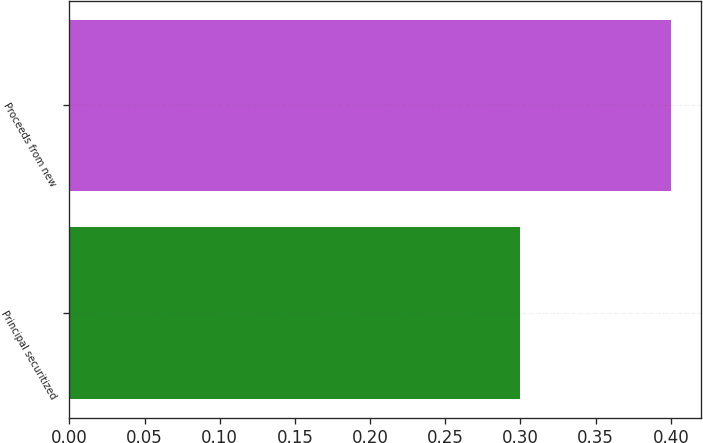Convert chart to OTSL. <chart><loc_0><loc_0><loc_500><loc_500><bar_chart><fcel>Principal securitized<fcel>Proceeds from new<nl><fcel>0.3<fcel>0.4<nl></chart> 